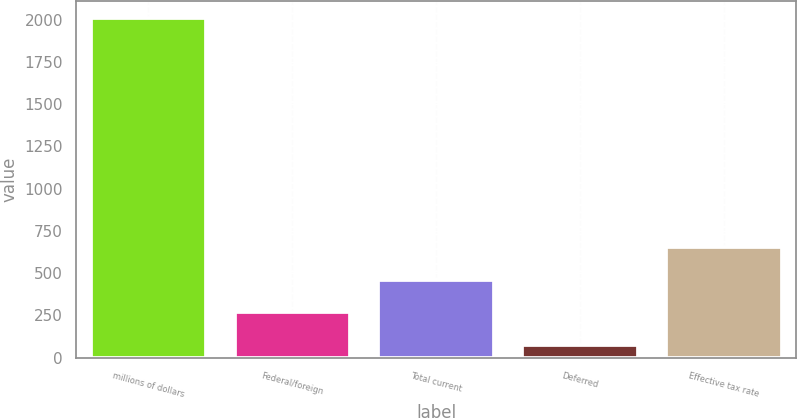Convert chart. <chart><loc_0><loc_0><loc_500><loc_500><bar_chart><fcel>millions of dollars<fcel>Federal/foreign<fcel>Total current<fcel>Deferred<fcel>Effective tax rate<nl><fcel>2008<fcel>268.21<fcel>461.52<fcel>74.9<fcel>654.83<nl></chart> 